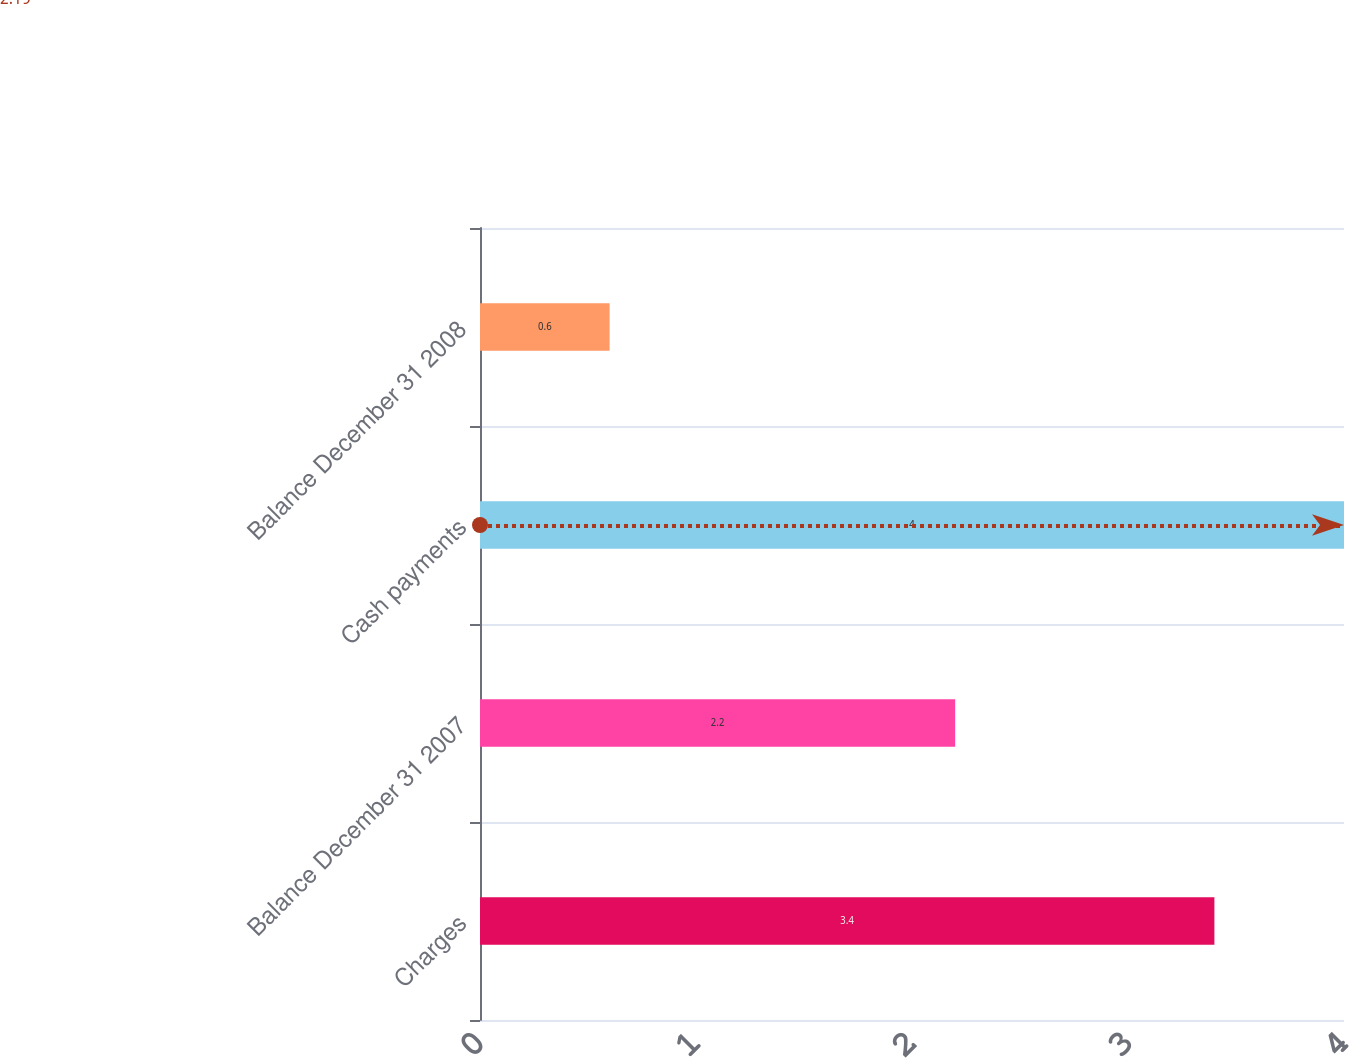Convert chart to OTSL. <chart><loc_0><loc_0><loc_500><loc_500><bar_chart><fcel>Charges<fcel>Balance December 31 2007<fcel>Cash payments<fcel>Balance December 31 2008<nl><fcel>3.4<fcel>2.2<fcel>4<fcel>0.6<nl></chart> 